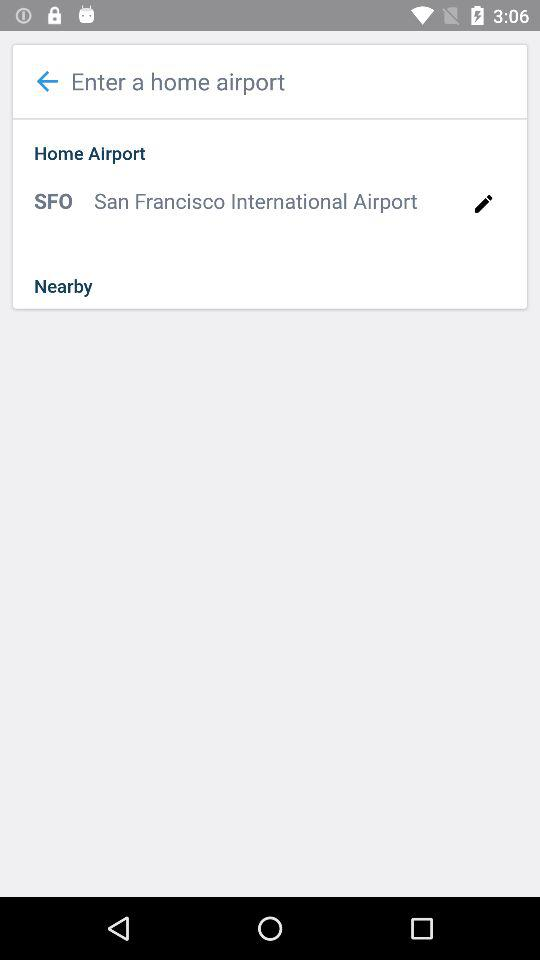What is the name of the application?
When the provided information is insufficient, respond with <no answer>. <no answer> 